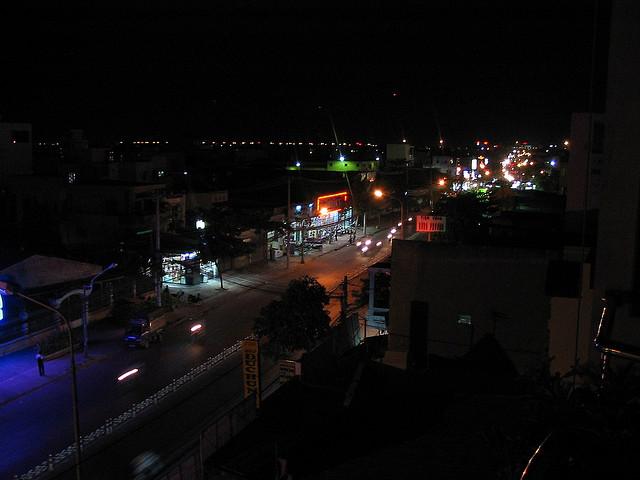Is it night time?
Short answer required. Yes. Did a Lamplighter light the street lights?
Keep it brief. No. Is there any city lights?
Concise answer only. Yes. 